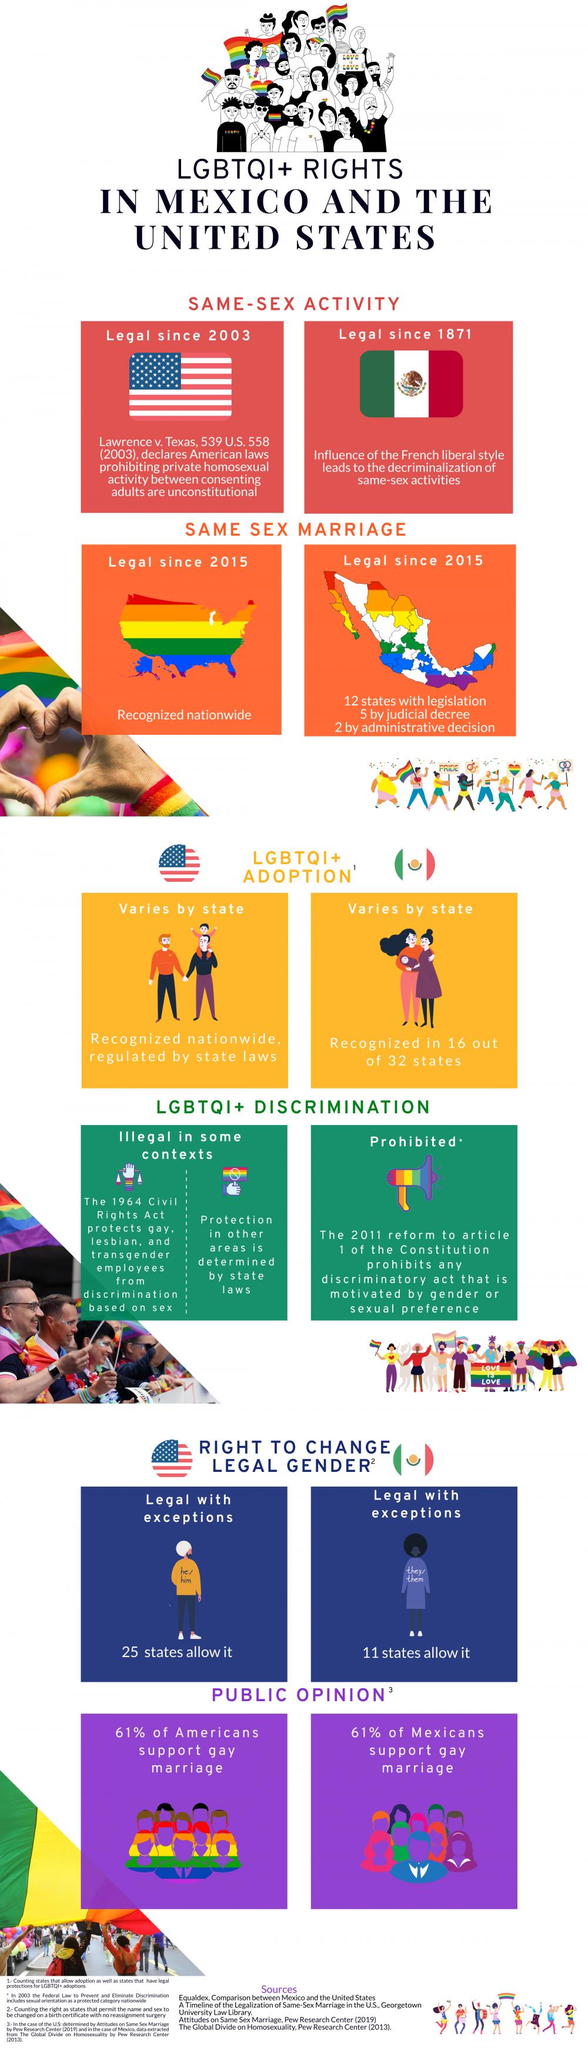List a handful of essential elements in this visual. Sixteen out of 32 states in Mexico recognize LGBTQI+ adoption. As of today, 25 states in the United States allow individuals to change their gender. 